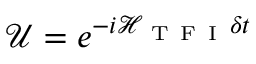Convert formula to latex. <formula><loc_0><loc_0><loc_500><loc_500>\mathcal { U } = e ^ { - i \mathcal { H } _ { T F I } \delta t }</formula> 